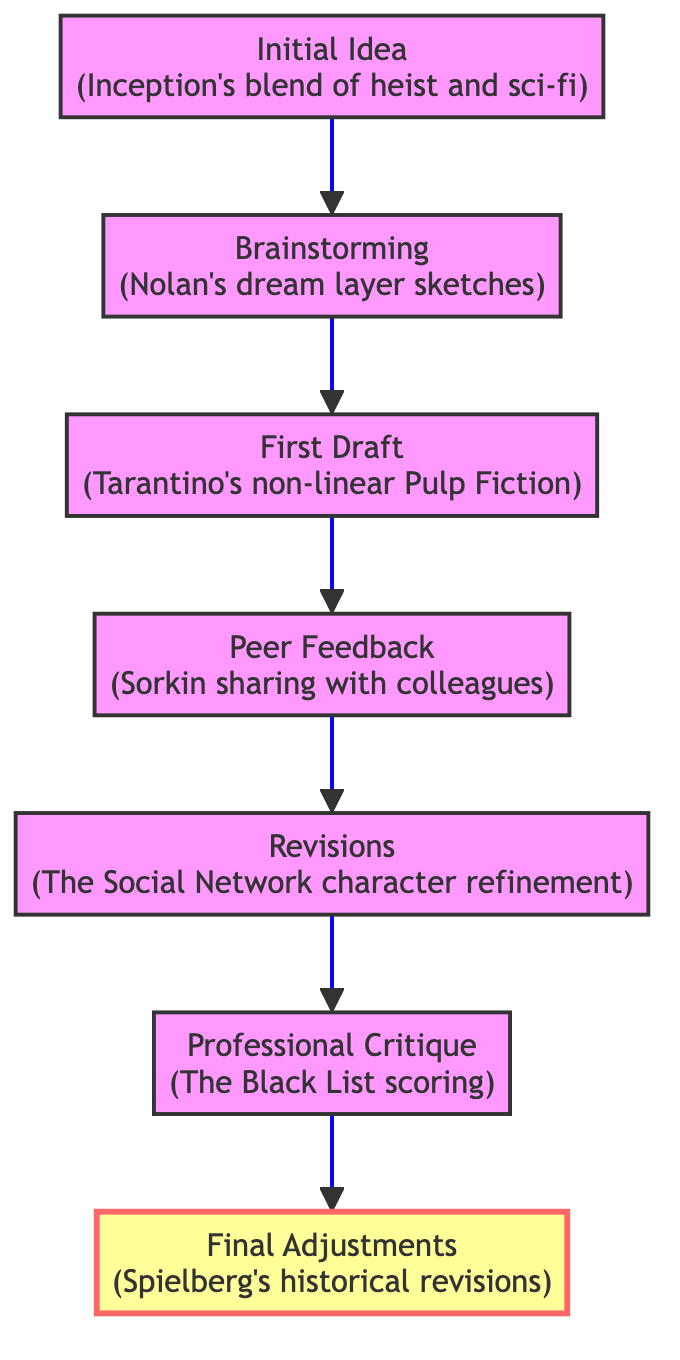What is the final stage in the flowchart? The final stage in the flowchart is the one at the top, which is labeled as "Final Adjustments."
Answer: Final Adjustments How many stages are shown in the diagram? The diagram lists a total of seven distinct stages, which include Initial Idea, Brainstorming, First Draft, Peer Feedback, Revisions, Professional Critique, and Final Adjustments.
Answer: Seven Which stage follows the First Draft? The stage that follows the First Draft is Peer Feedback, as indicated by the arrow pointing from the First Draft node to the Peer Feedback node in the flowchart.
Answer: Peer Feedback What is the real-world example for Revisions? The real-world example provided for Revisions is "The Social Network character refinement," as noted in the description for that stage.
Answer: The Social Network character refinement What is the relationship between Initial Idea and Final Adjustments? The Initial Idea is the starting point, while Final Adjustments is the last stage in the flowchart, indicating a progression from the concept's inception to its final refinement, linked by the flow of stages in between.
Answer: Progression from inception to final refinement What type of feedback does the Peer Feedback stage focus on? The Peer Feedback stage focuses on initial thoughts and opinions from writer's groups, forums, or trusted friends, as noted in the description.
Answer: Initial thoughts Who is one example of a professional critique recipient listed in the diagram? One example of a professional critique recipient mentioned is "The Black List," which is indicated in the context of the Professional Critique stage.
Answer: The Black List What key element does brainstorming emphasize? The brainstorming stage emphasizes gathering ideas, character development, and creating outlines or mind maps, which are key aspects of this stage's description.
Answer: Gathering ideas What does the arrow direction indicate in this flowchart? The arrow direction indicates a progression or flow from one stage to the next, showing the movement through the stages of developing a screenplay from initial concept to final critique.
Answer: Progression through stages 